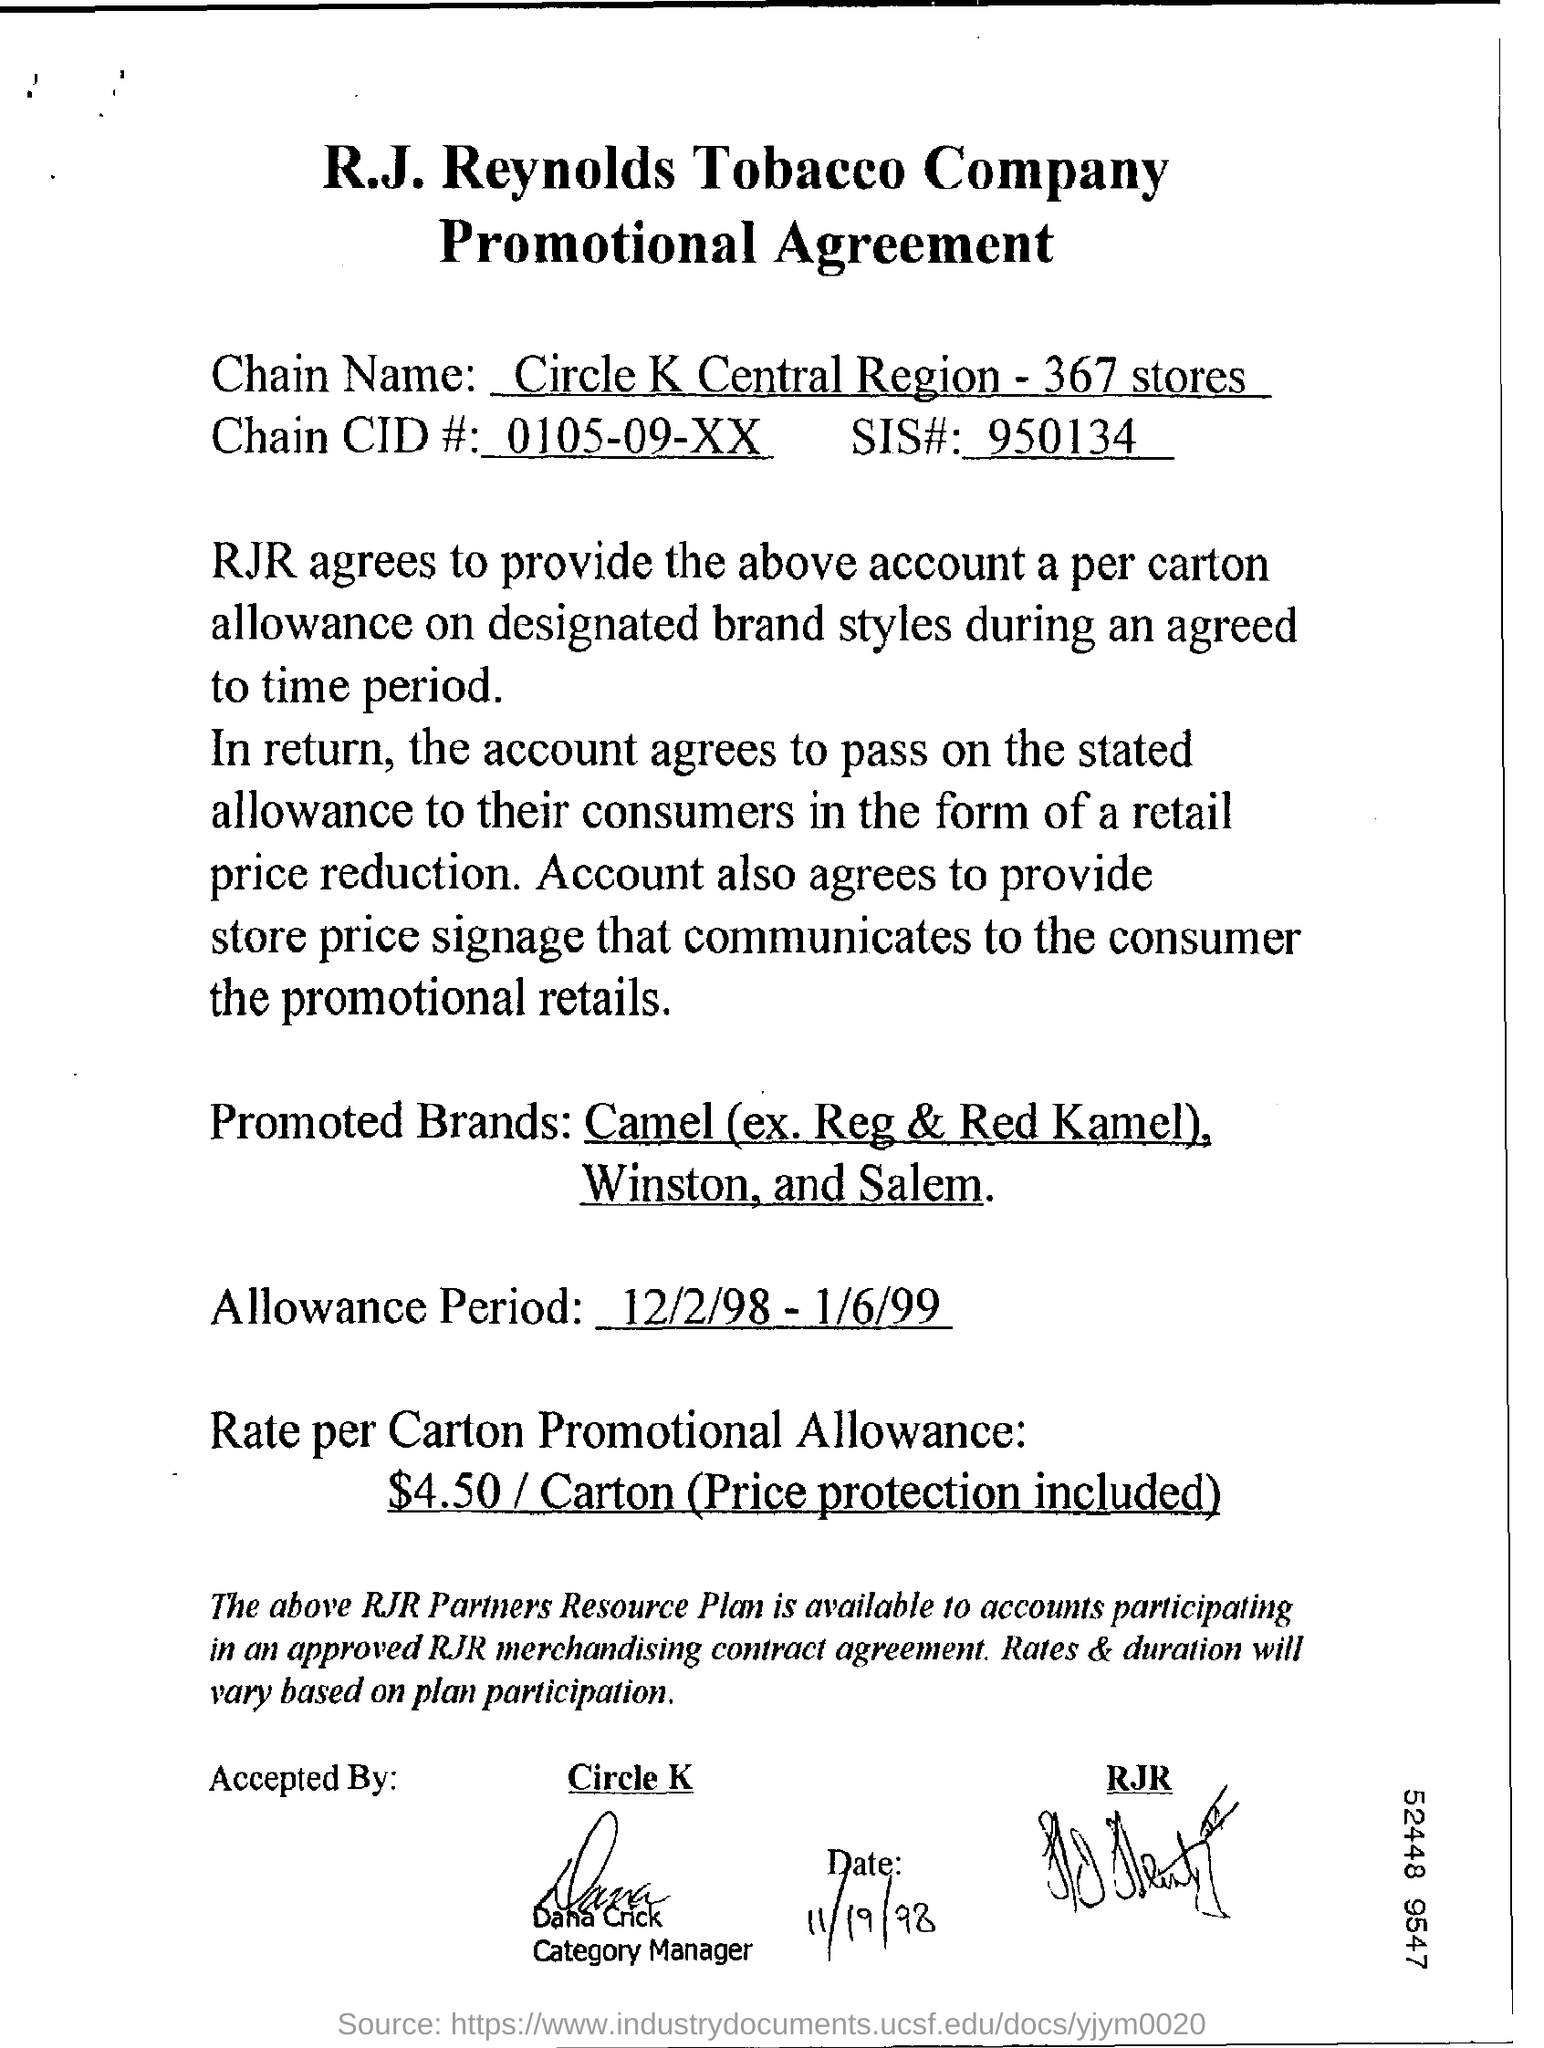What kind of agreement of r.j. reynolds tobacco company?
Your response must be concise. Promotional agreement. What is the chain name?
Offer a very short reply. Circle k central region - 367 stores. What is the number of sis#?
Offer a very short reply. 950134. What is the allowance period ?
Provide a short and direct response. 12/2/98 -1/6/99. What is the rate per carton promotional allowance?
Provide a succinct answer. $4.50/ Carton (Price protection included). Who is the designated as category manger?
Your answer should be very brief. Dana Crick. 